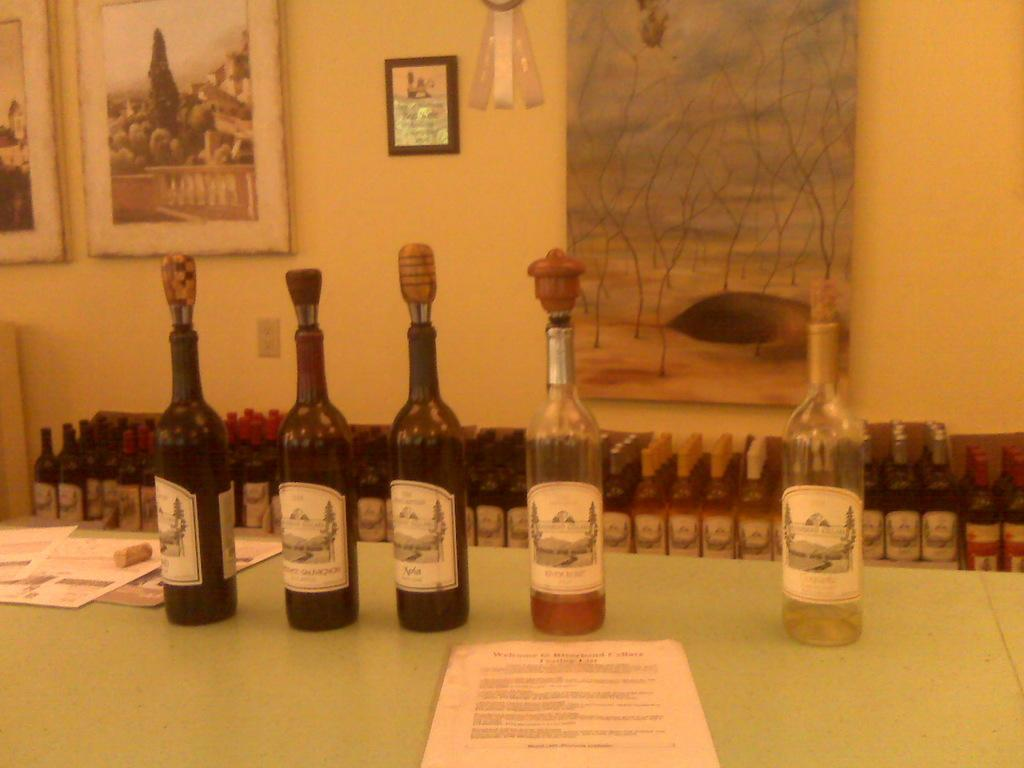<image>
Summarize the visual content of the image. Several bottles including Alpha, lined up on a table along with some papers. 